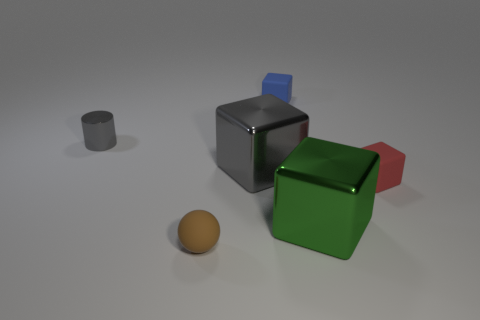Are there more matte blocks behind the small gray object than big red matte cylinders?
Provide a succinct answer. Yes. Is the gray metal cube the same size as the rubber ball?
Offer a terse response. No. What is the material of the other small thing that is the same shape as the tiny blue object?
Your answer should be compact. Rubber. Is there anything else that is the same material as the big green block?
Your answer should be very brief. Yes. How many yellow things are either large metal things or tiny shiny balls?
Your response must be concise. 0. There is a tiny object that is behind the small gray metallic cylinder; what material is it?
Offer a terse response. Rubber. Are there more rubber balls than small blue rubber cylinders?
Provide a short and direct response. Yes. Is the shape of the tiny thing that is on the left side of the brown matte sphere the same as  the blue matte object?
Provide a succinct answer. No. How many things are on the left side of the large green metal thing and in front of the red block?
Your answer should be very brief. 1. How many large green things have the same shape as the red matte object?
Offer a very short reply. 1. 